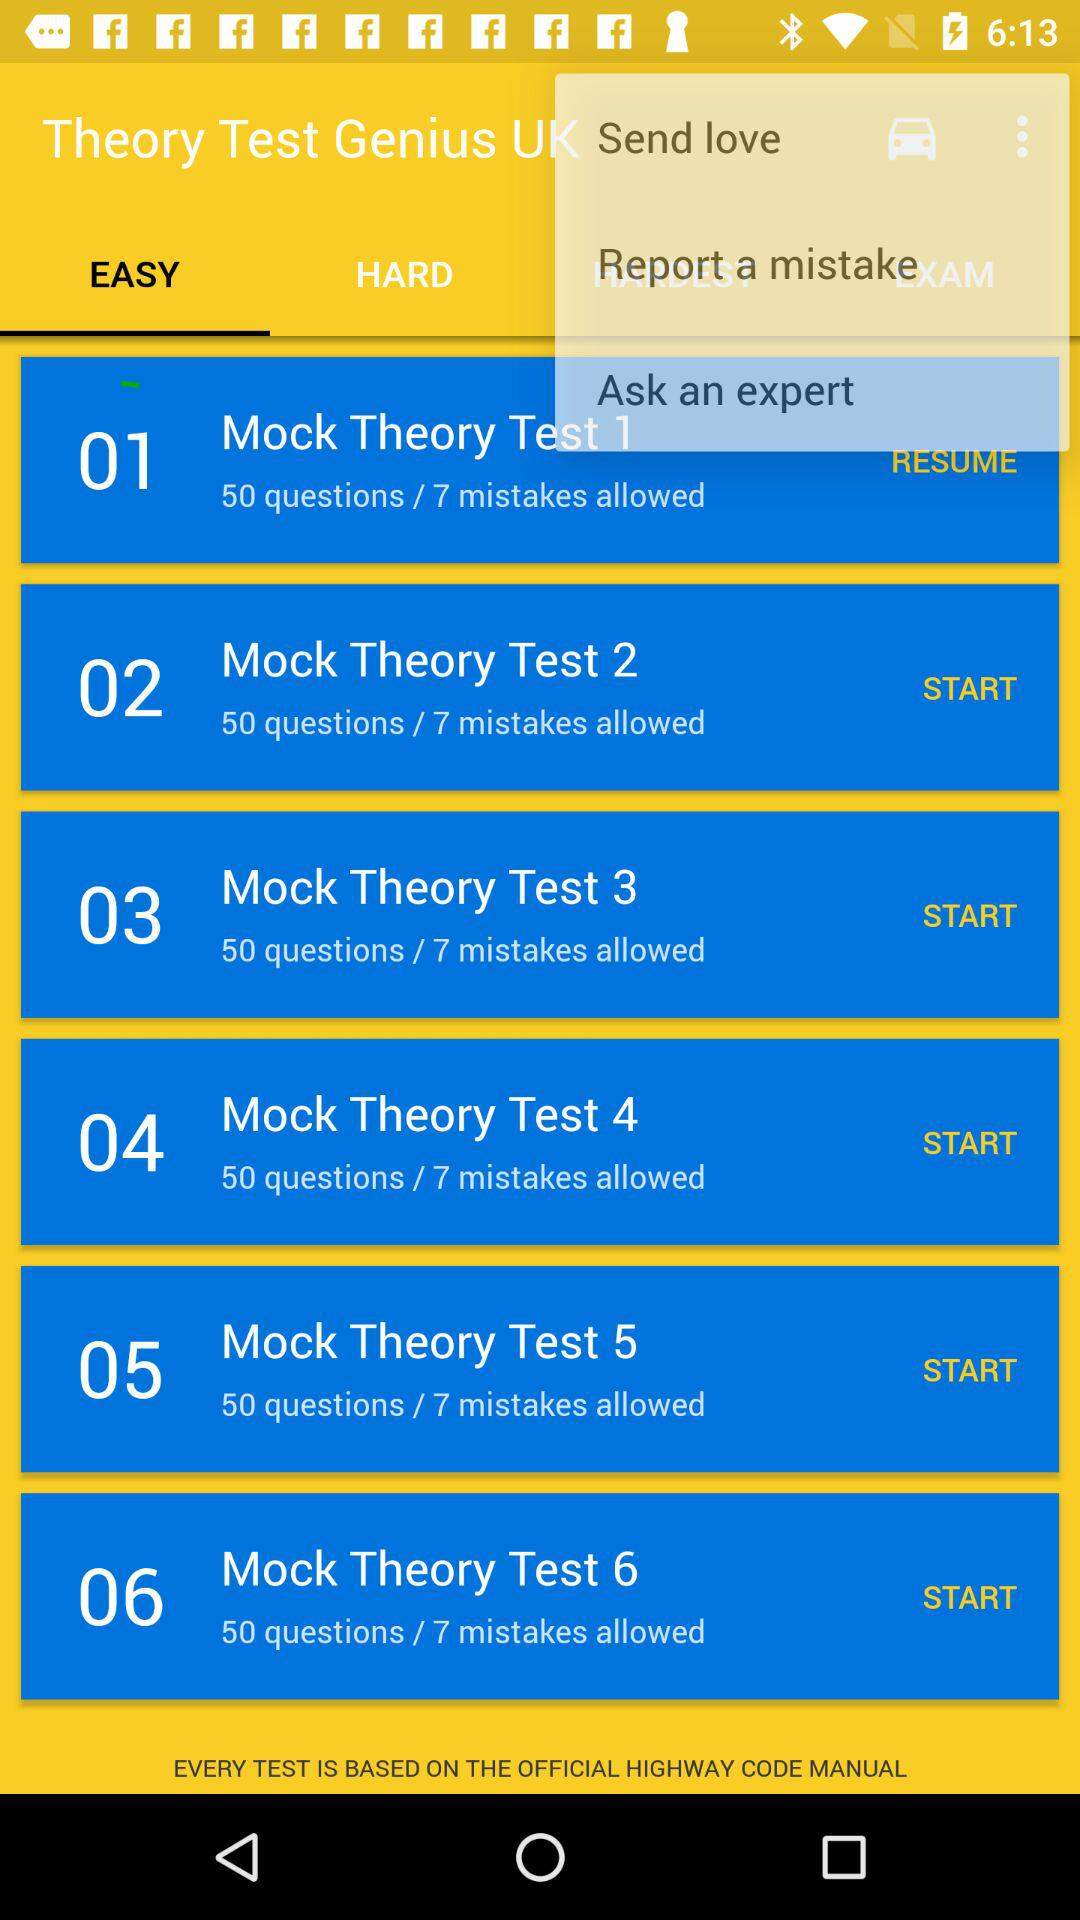How many mistakes are allowed in "Mock Theory Test 4"? There are 7 mistakes allowed in "Mock Theory Test 4". 